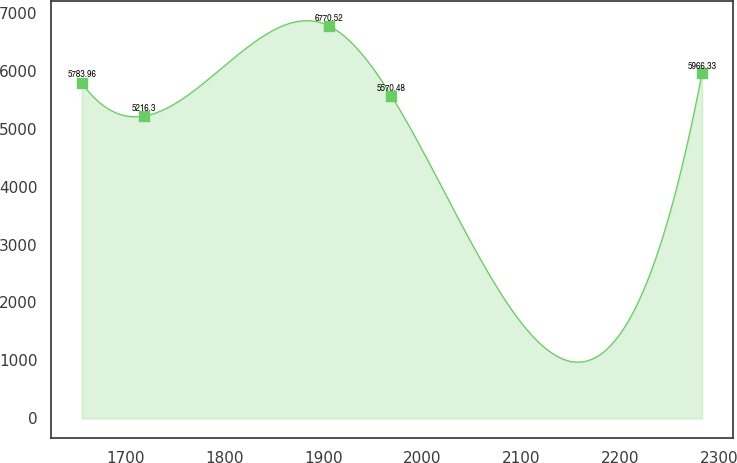Convert chart. <chart><loc_0><loc_0><loc_500><loc_500><line_chart><ecel><fcel>Unnamed: 1<nl><fcel>1655.47<fcel>5783.96<nl><fcel>1718.22<fcel>5216.3<nl><fcel>1905.67<fcel>6770.52<nl><fcel>1968.43<fcel>5570.48<nl><fcel>2283.02<fcel>5966.33<nl></chart> 